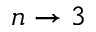<formula> <loc_0><loc_0><loc_500><loc_500>n \rightarrow 3</formula> 